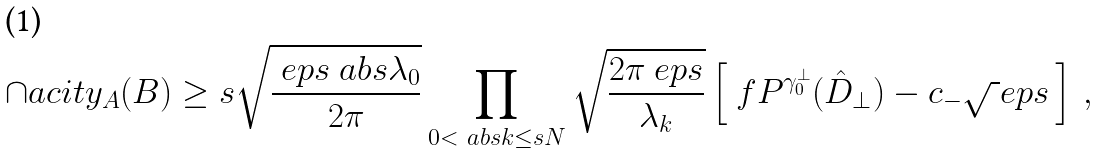Convert formula to latex. <formula><loc_0><loc_0><loc_500><loc_500>\cap a c i t y _ { A } ( B ) \geq s \sqrt { \frac { \ e p s \ a b s { \lambda _ { 0 } } } { 2 \pi } } \prod _ { 0 < \ a b s { k } \leq s N } \sqrt { \frac { 2 \pi \ e p s } { \lambda _ { k } } } \left [ \ f P ^ { \gamma _ { 0 } ^ { \perp } } ( \hat { D } _ { \perp } ) - c _ { - } \sqrt { \ } e p s \, \right ] \, ,</formula> 